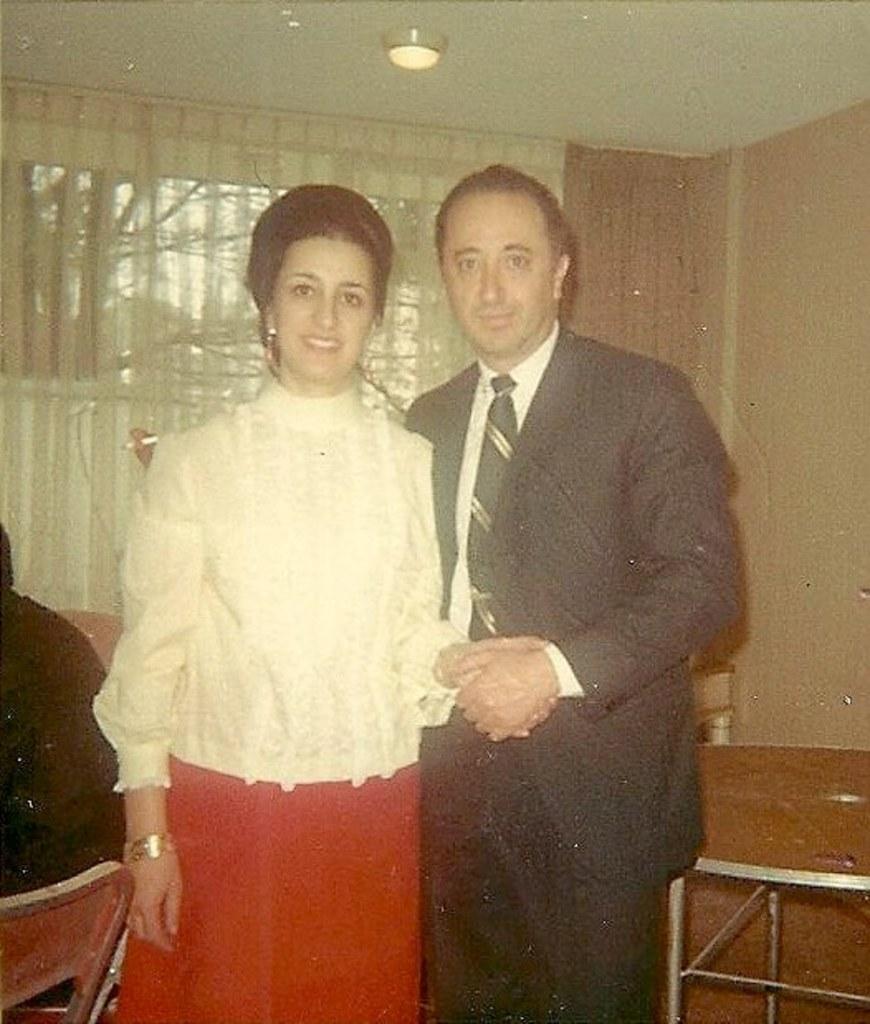In one or two sentences, can you explain what this image depicts? In this picture I can see a man and a woman standing and smiling, there is a table, a chair, there is another person, and in the background there is a light, there are curtains, there is a window and a wall. 